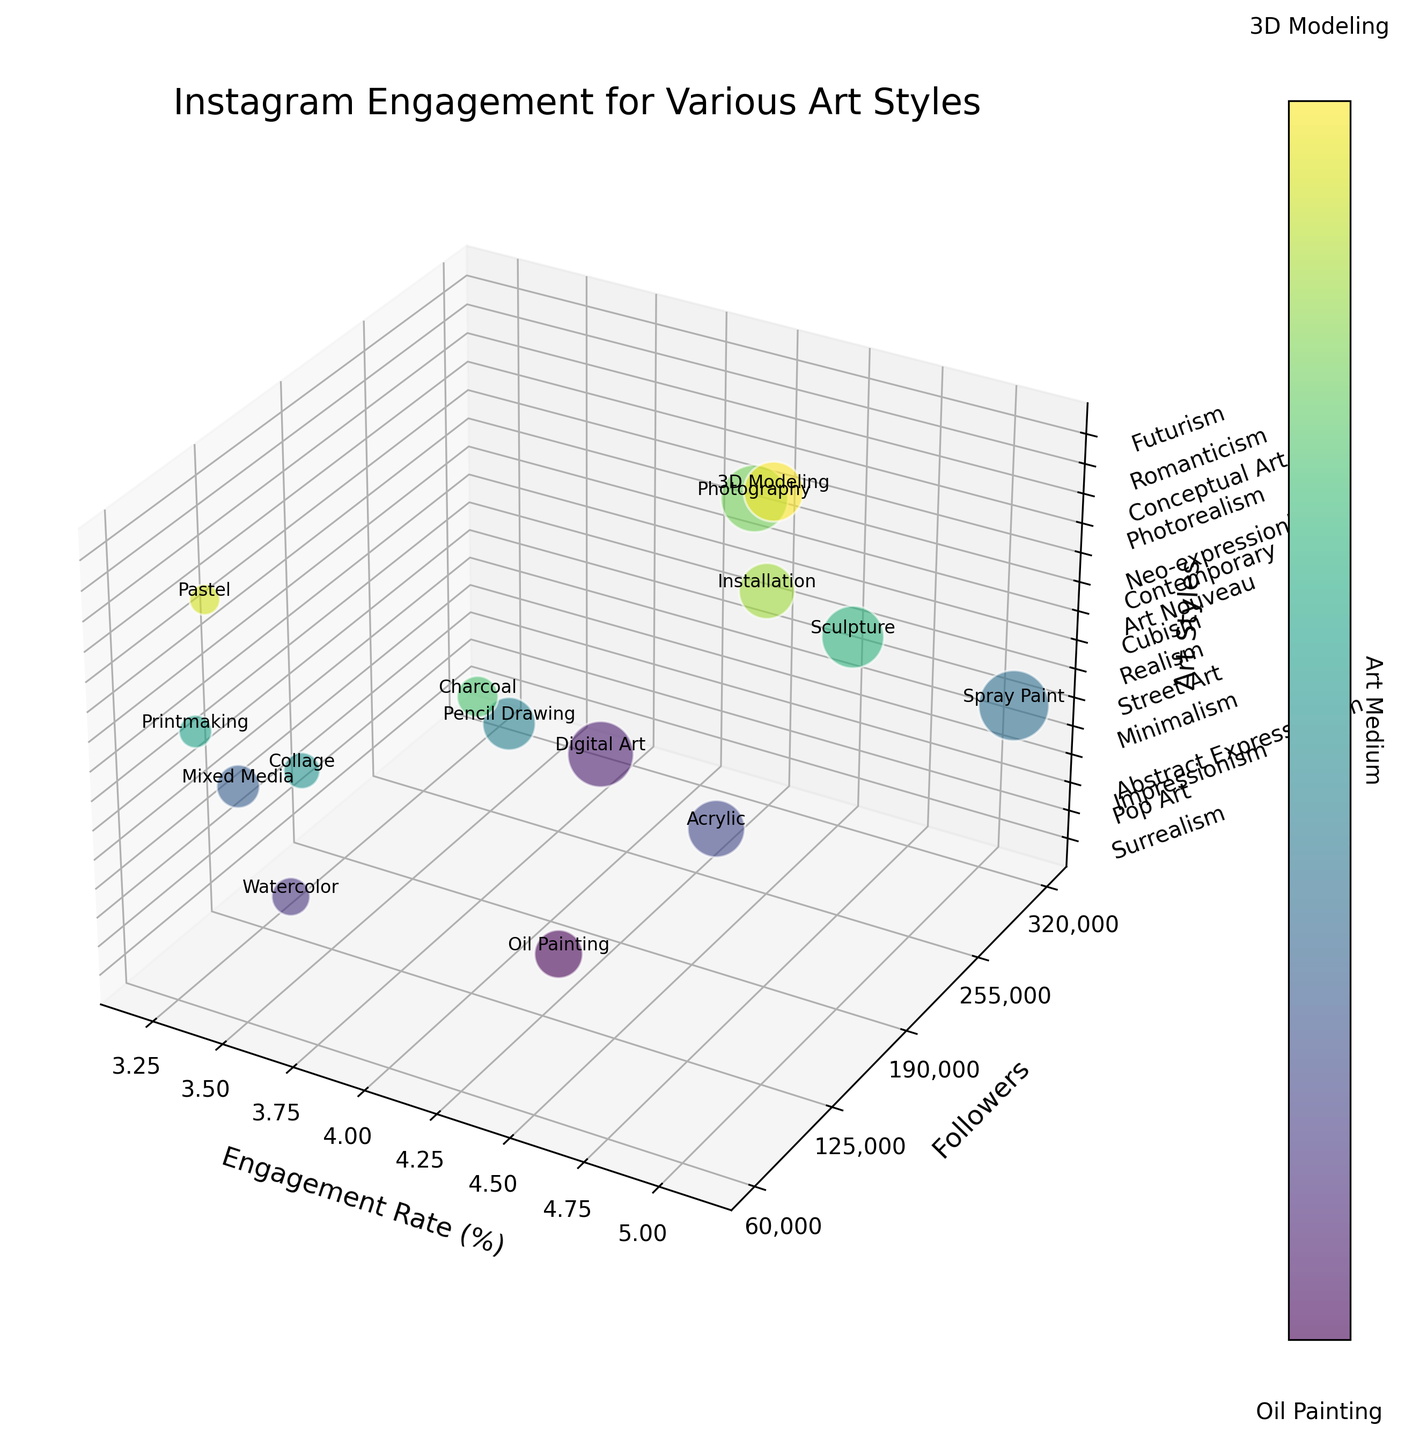How many art styles are displayed in the 3D bubble chart? To find the number of art styles, one can simply count the z-axis labels. The z-axis labels provide the names of the different art styles shown in the chart.
Answer: 15 Which art style has the highest engagement rate? By looking at the x-axis values, the art style with the highest engagement rate is the one positioned furthest to the right.
Answer: Street Art What is the follower count for the art style with the lowest engagement rate? First, identify the art style with the lowest engagement rate on the x-axis. Then, read the corresponding value on the y-axis for that data point.
Answer: Minimalism has 120,000 followers Compare the engagement rates of Pop Art and Contemporary styles. Which one is higher? Locate both Pop Art and Contemporary by their z-axis labels. Compare their x-axis values to see which one has a higher engagement rate.
Answer: Contemporary What is the difference in follower counts between Impressionism and Realism? Identify the follower counts for Impressionism and Realism by looking at their positions on the y-axis. Then, subtract the follower count of Impressionism from that of Realism.
Answer: 85,000 Which art style has a greater engagement rate, Futurism or Photorealism? Locate both Futurism and Photorealism by their z-axis labels. Compare their x-axis values to see which one has a higher engagement rate.
Answer: Photorealism Out of all the art styles, which has the second highest engagement rate and how many followers does it have? By sequentially looking at the engagement rates (x-axis values), identify the second highest rate and then find the corresponding follower count on the y-axis.
Answer: Futurism with 230,000 followers Which mediums correspond to the highest and lowest engagement rates? Identify the data points with the highest and lowest x-axis values. Then read the textual annotation for the medium for these points.
Answer: Highest: Spray Paint, Lowest: Mixed Media How does the bubble size for Abstract Expressionism compare to that of Impressionism in terms of follower count? Check the bubble sizes, which are proportional to the followers. Abstract Expressionism has a larger bubble size compared to Impressionism, hence more followers.
Answer: Abstract Expressionism has more followers For the art style with the median engagement rate, what is the medium used? First, arrange the engagement rates in ascending order. The median engagement rate will be the one in the middle of this ordered list. Locate the corresponding art style and read the associated medium written on the bubble.
Answer: Cubism and the medium is Collage 